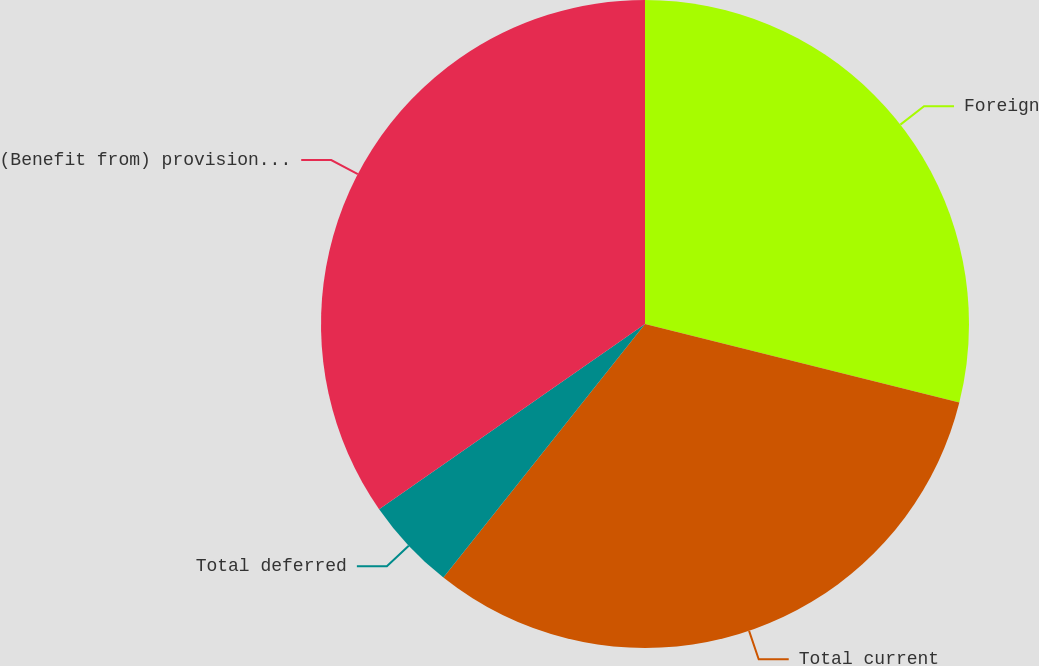Convert chart to OTSL. <chart><loc_0><loc_0><loc_500><loc_500><pie_chart><fcel>Foreign<fcel>Total current<fcel>Total deferred<fcel>(Benefit from) provision for<nl><fcel>28.9%<fcel>31.79%<fcel>4.63%<fcel>34.68%<nl></chart> 